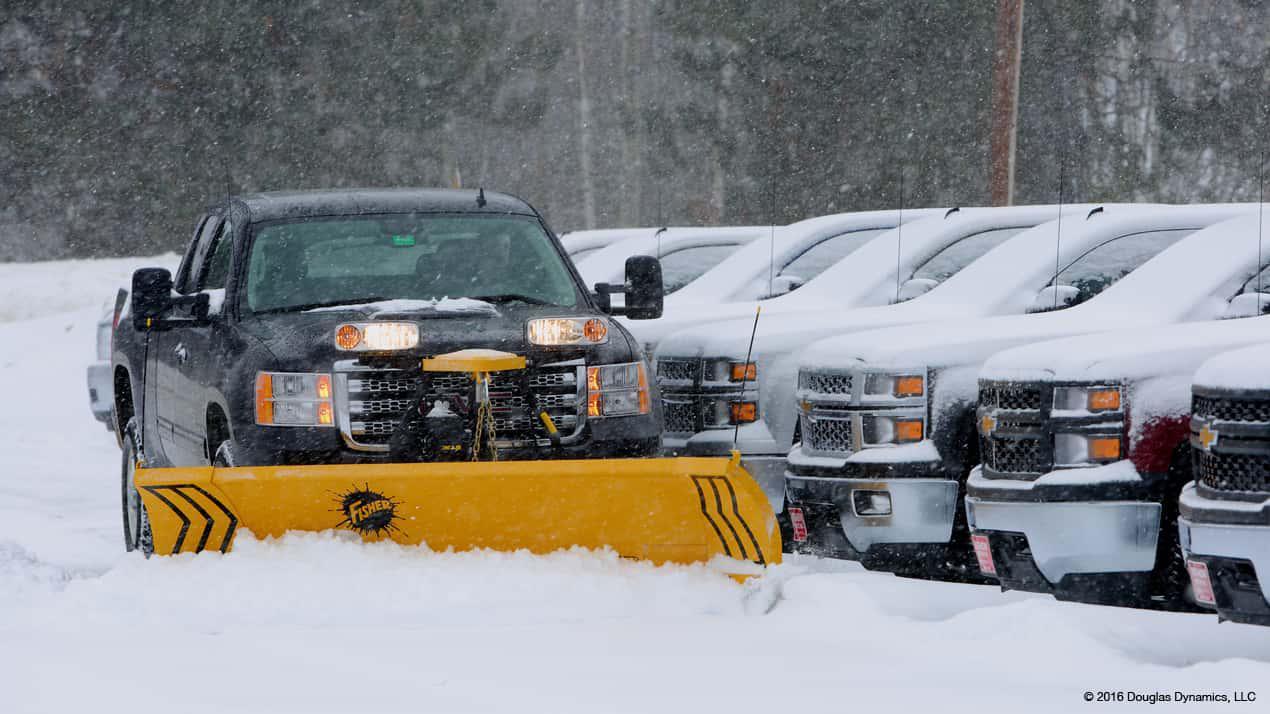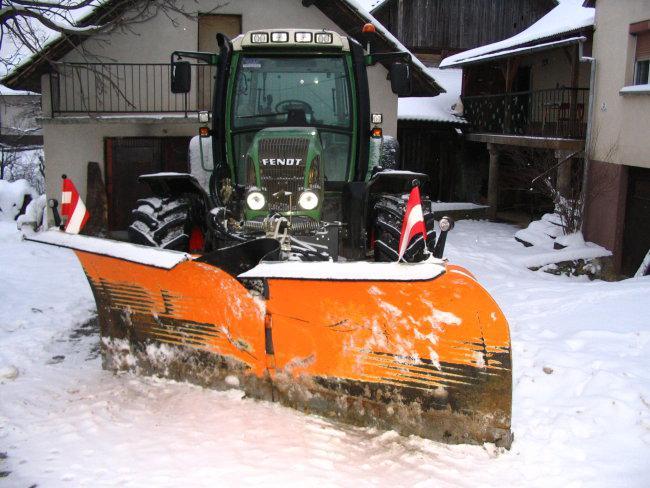The first image is the image on the left, the second image is the image on the right. For the images shown, is this caption "All images include a vehicle pushing a bright yellow plow through snow, and one image features a truck with a bright yellow cab." true? Answer yes or no. No. The first image is the image on the left, the second image is the image on the right. Analyze the images presented: Is the assertion "A pickup truck with a yellow bulldozer front attachment is pushing a pile of snow." valid? Answer yes or no. Yes. 